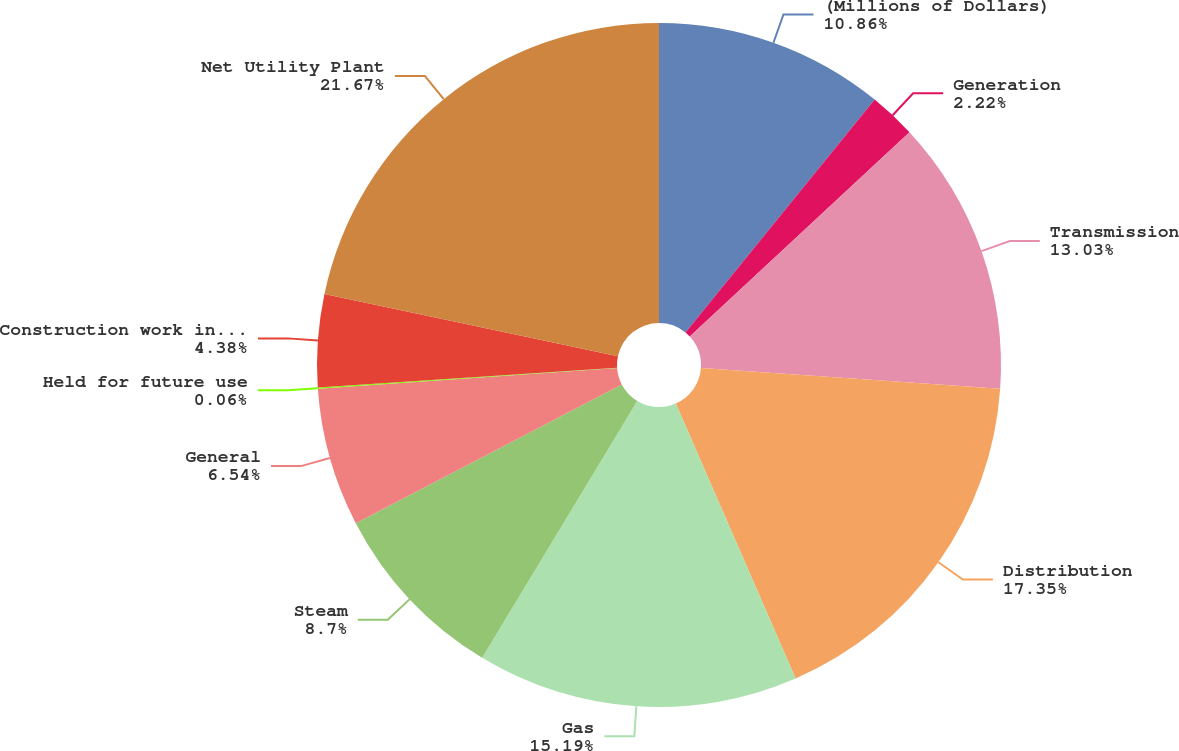<chart> <loc_0><loc_0><loc_500><loc_500><pie_chart><fcel>(Millions of Dollars)<fcel>Generation<fcel>Transmission<fcel>Distribution<fcel>Gas<fcel>Steam<fcel>General<fcel>Held for future use<fcel>Construction work in progress<fcel>Net Utility Plant<nl><fcel>10.86%<fcel>2.22%<fcel>13.03%<fcel>17.35%<fcel>15.19%<fcel>8.7%<fcel>6.54%<fcel>0.06%<fcel>4.38%<fcel>21.67%<nl></chart> 